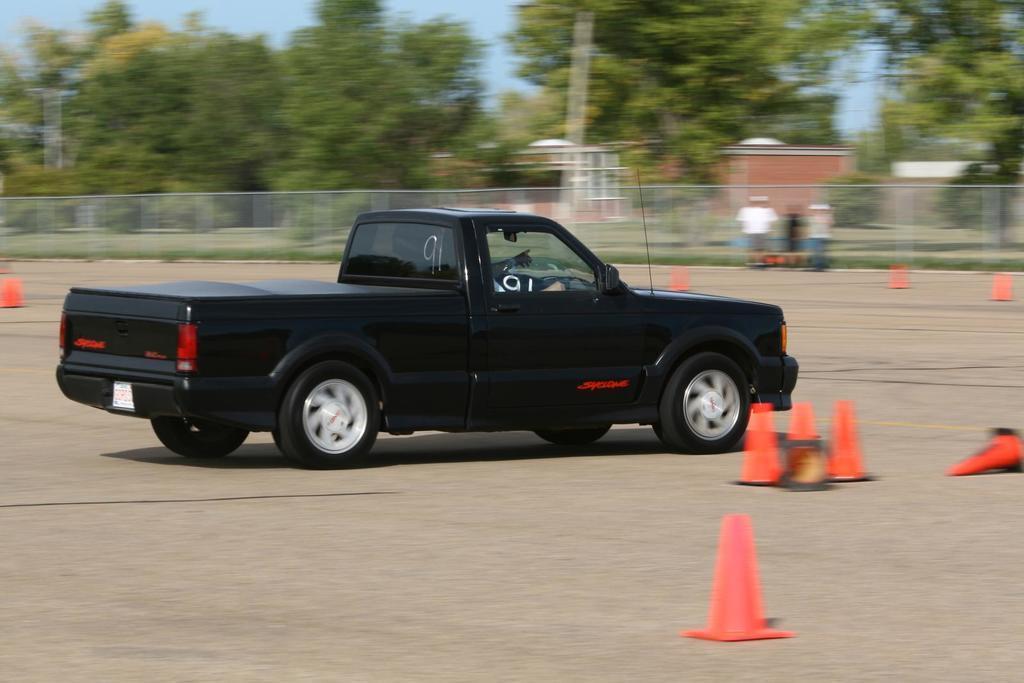Describe this image in one or two sentences. In the center of the image a person is riding a truck. In the background of the image we can see some persons, divider cones, mesh, houses, trees, pole. At the bottom of the image there is a ground. At the top of the image there is a sky. 